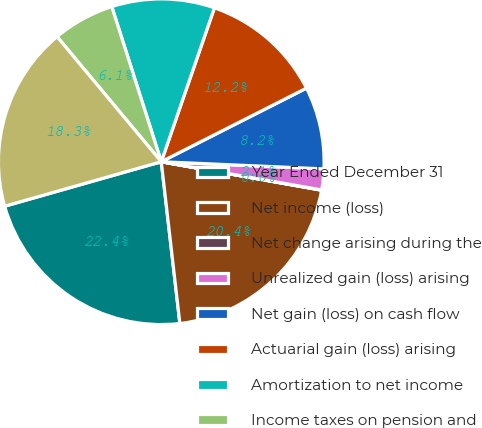Convert chart to OTSL. <chart><loc_0><loc_0><loc_500><loc_500><pie_chart><fcel>Year Ended December 31<fcel>Net income (loss)<fcel>Net change arising during the<fcel>Unrealized gain (loss) arising<fcel>Net gain (loss) on cash flow<fcel>Actuarial gain (loss) arising<fcel>Amortization to net income<fcel>Income taxes on pension and<fcel>Comprehensive income (loss)<nl><fcel>22.42%<fcel>20.38%<fcel>0.03%<fcel>2.07%<fcel>8.17%<fcel>12.24%<fcel>10.21%<fcel>6.14%<fcel>18.35%<nl></chart> 